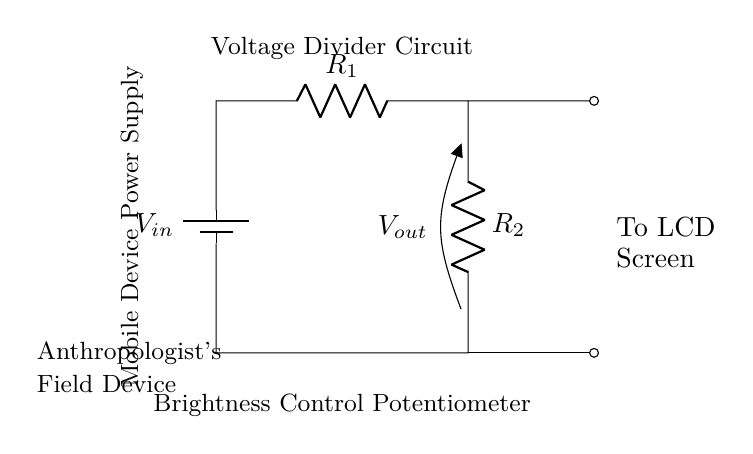What is the input voltage of the circuit? The input voltage is labeled as V_in, indicating the voltage supplied to the circuit.
Answer: V_in What are the resistors used in the voltage divider? The circuit diagram shows two resistors labeled R_1 and R_2, which are part of the voltage divider configuration.
Answer: R_1 and R_2 What is the purpose of the voltage divider in this circuit? The voltage divider adjusts the output voltage, V_out, which controls the screen brightness for the LCD.
Answer: Adjust screen brightness What is the output voltage represented as in the circuit? The output voltage is noted as V_out, which is taken from the voltage divider and connected to the LCD screen.
Answer: V_out How many components does the circuit comprise? The circuit contains three main components: one battery and two resistors, making a total of three components in the diagram.
Answer: Three components What is the function of the brightness control potentiometer? The brightness control potentiometer is used to vary the resistance in the circuit, affecting the voltage across R_2 and thereby controlling the brightness of the screen.
Answer: Control brightness Why is the mobile device power supply mentioned in the circuit? The mobile device power supply is mentioned as it provides the necessary voltage to the circuit to function, which is critical for adjusting the screen brightness.
Answer: Power supply 